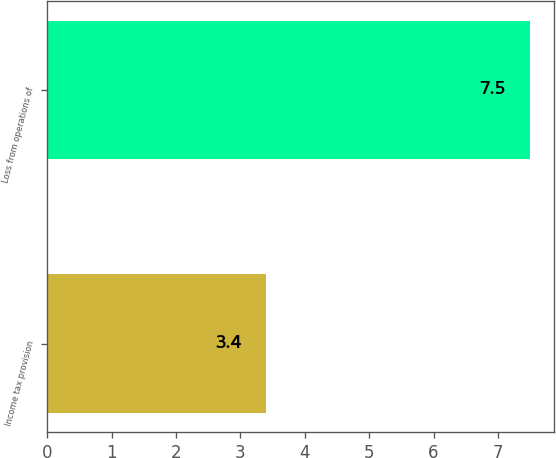<chart> <loc_0><loc_0><loc_500><loc_500><bar_chart><fcel>Income tax provision<fcel>Loss from operations of<nl><fcel>3.4<fcel>7.5<nl></chart> 